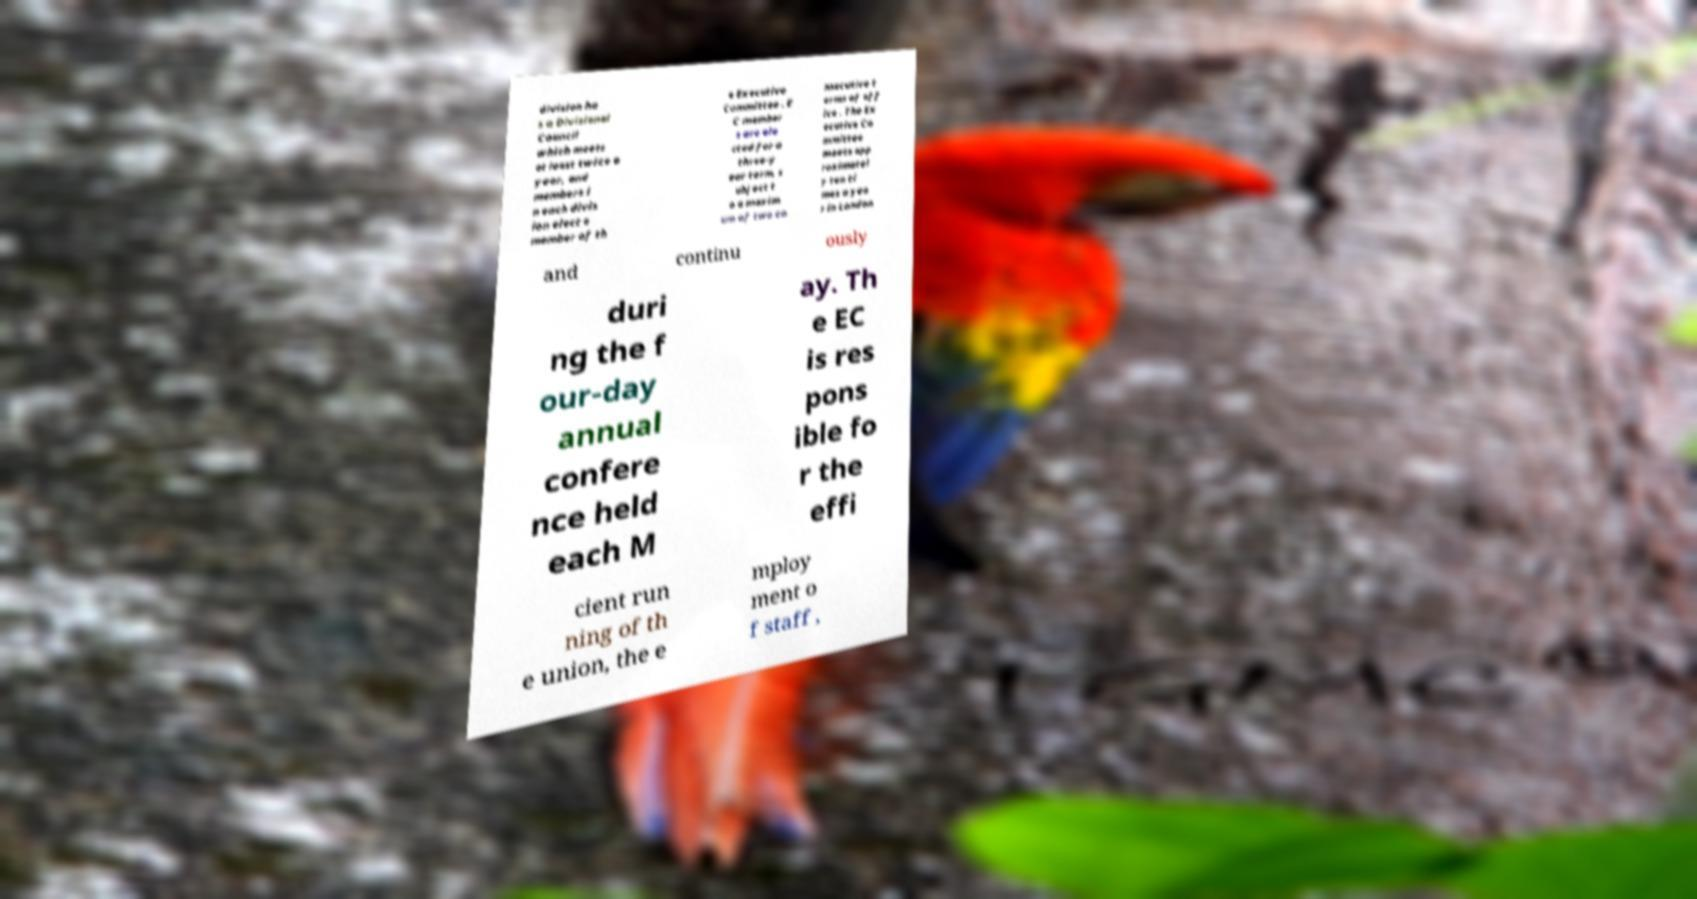Can you accurately transcribe the text from the provided image for me? division ha s a Divisional Council which meets at least twice a year, and members i n each divis ion elect a member of th e Executive Committee . E C member s are ele cted for a three-y ear term, s ubject t o a maxim um of two co nsecutive t erms of off ice . The Ex ecutive Co mmittee meets app roximatel y ten ti mes a yea r in London and continu ously duri ng the f our-day annual confere nce held each M ay. Th e EC is res pons ible fo r the effi cient run ning of th e union, the e mploy ment o f staff , 